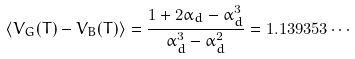Convert formula to latex. <formula><loc_0><loc_0><loc_500><loc_500>\langle V _ { G } ( T ) - V _ { B } ( T ) \rangle = \frac { 1 + 2 \alpha _ { d } - \alpha _ { d } ^ { 3 } } { \alpha _ { d } ^ { 3 } - \alpha _ { d } ^ { 2 } } = 1 . 1 3 9 3 5 3 \cdots</formula> 